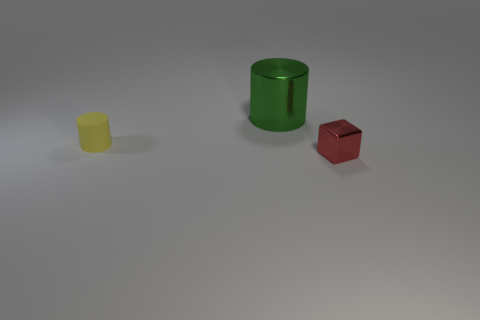Subtract 2 cylinders. How many cylinders are left? 0 Add 2 red metallic things. How many objects exist? 5 Subtract all blocks. How many objects are left? 2 Add 3 tiny yellow spheres. How many tiny yellow spheres exist? 3 Subtract 0 gray cylinders. How many objects are left? 3 Subtract all yellow cubes. Subtract all purple cylinders. How many cubes are left? 1 Subtract all large green shiny blocks. Subtract all green things. How many objects are left? 2 Add 1 tiny cylinders. How many tiny cylinders are left? 2 